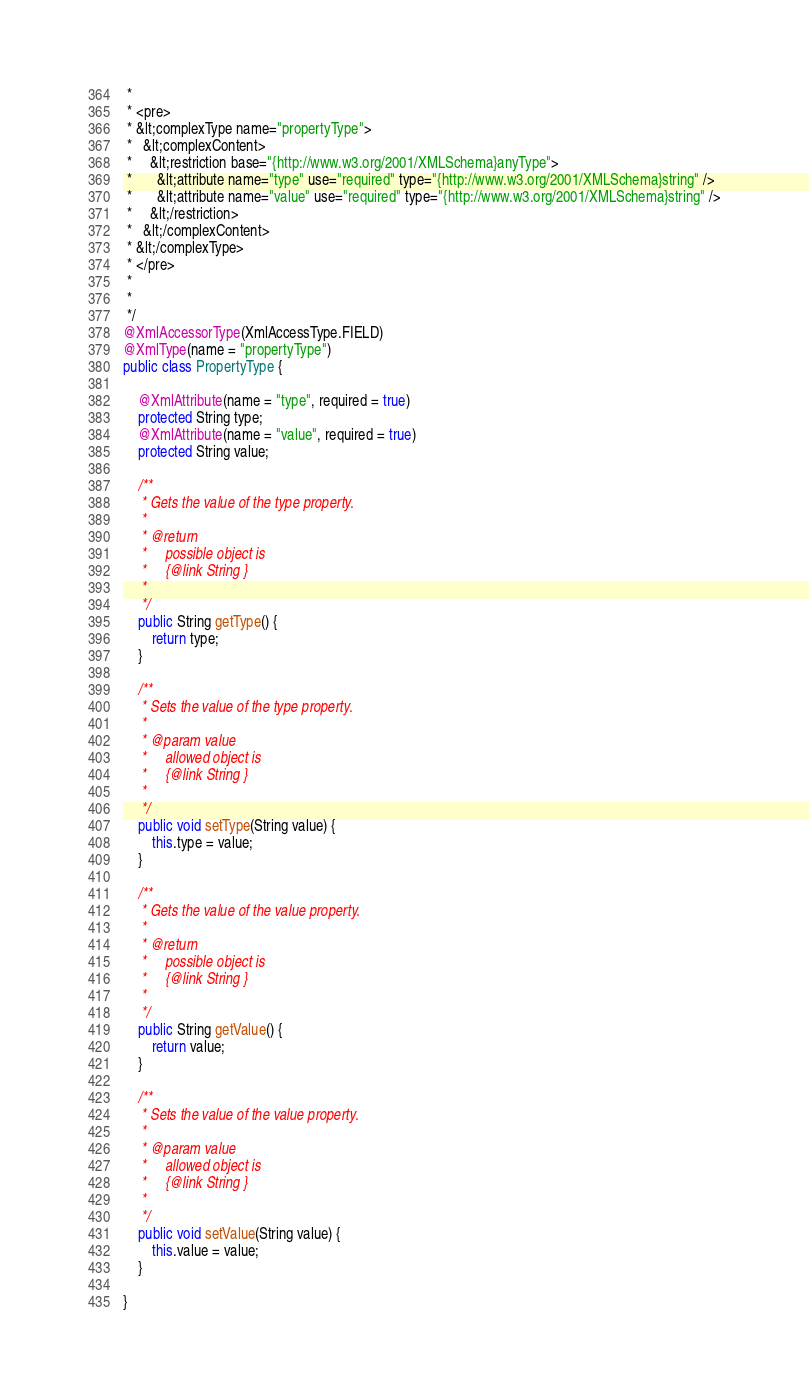<code> <loc_0><loc_0><loc_500><loc_500><_Java_> * 
 * <pre>
 * &lt;complexType name="propertyType">
 *   &lt;complexContent>
 *     &lt;restriction base="{http://www.w3.org/2001/XMLSchema}anyType">
 *       &lt;attribute name="type" use="required" type="{http://www.w3.org/2001/XMLSchema}string" />
 *       &lt;attribute name="value" use="required" type="{http://www.w3.org/2001/XMLSchema}string" />
 *     &lt;/restriction>
 *   &lt;/complexContent>
 * &lt;/complexType>
 * </pre>
 * 
 * 
 */
@XmlAccessorType(XmlAccessType.FIELD)
@XmlType(name = "propertyType")
public class PropertyType {

    @XmlAttribute(name = "type", required = true)
    protected String type;
    @XmlAttribute(name = "value", required = true)
    protected String value;

    /**
     * Gets the value of the type property.
     * 
     * @return
     *     possible object is
     *     {@link String }
     *     
     */
    public String getType() {
        return type;
    }

    /**
     * Sets the value of the type property.
     * 
     * @param value
     *     allowed object is
     *     {@link String }
     *     
     */
    public void setType(String value) {
        this.type = value;
    }

    /**
     * Gets the value of the value property.
     * 
     * @return
     *     possible object is
     *     {@link String }
     *     
     */
    public String getValue() {
        return value;
    }

    /**
     * Sets the value of the value property.
     * 
     * @param value
     *     allowed object is
     *     {@link String }
     *     
     */
    public void setValue(String value) {
        this.value = value;
    }

}
</code> 